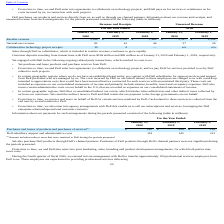According to Vmware's financial document, What were customer deposits resulting from transactions with Dell in 2020? According to the financial document, $194 million. The relevant text states: "eposits resulting from transactions with Dell were $194 million and $85 million as of January 31, 2020 and February 1, 2019, respectively...." Also, How does Dell purchase products and services from the company? directly from us, as well as through our channel partners. The document states: "Dell purchases our products and services directly from us, as well as through our channel partners. Information about our revenue and receipts, and..." Also, What was the reseller revenue in 2018? According to the financial document, 1,464 (in millions). The relevant text states: "Reseller revenue $ 3,288 $ 2,355 $ 1,464 $ 3,787 $ 2,554..." Also, can you calculate: What was the change in unearned reseller revenue between 2019 and 2020?  Based on the calculation: 3,787-2,554, the result is 1233 (in millions). This is based on the information: "eseller revenue $ 3,288 $ 2,355 $ 1,464 $ 3,787 $ 2,554 Reseller revenue $ 3,288 $ 2,355 $ 1,464 $ 3,787 $ 2,554..." The key data points involved are: 2,554, 3,787. Also, can you calculate: What was the change in Collaborative technology project receipts revenue between 2019 and 2020? Based on the calculation: 10-4, the result is 6 (in millions). This is based on the information: "Collaborative technology project receipts 10 4 — n/a n/a Collaborative technology project receipts 10 4 — n/a n/a..." The key data points involved are: 10, 4. Also, can you calculate: What was the percentage change in the internal-use revenue between 2019 and 2020? To answer this question, I need to perform calculations using the financial data. The calculation is: (82-41)/41, which equals 100 (percentage). This is based on the information: "Internal-use revenue 82 41 46 57 29 Internal-use revenue 82 41 46 57 29..." The key data points involved are: 41, 82. 